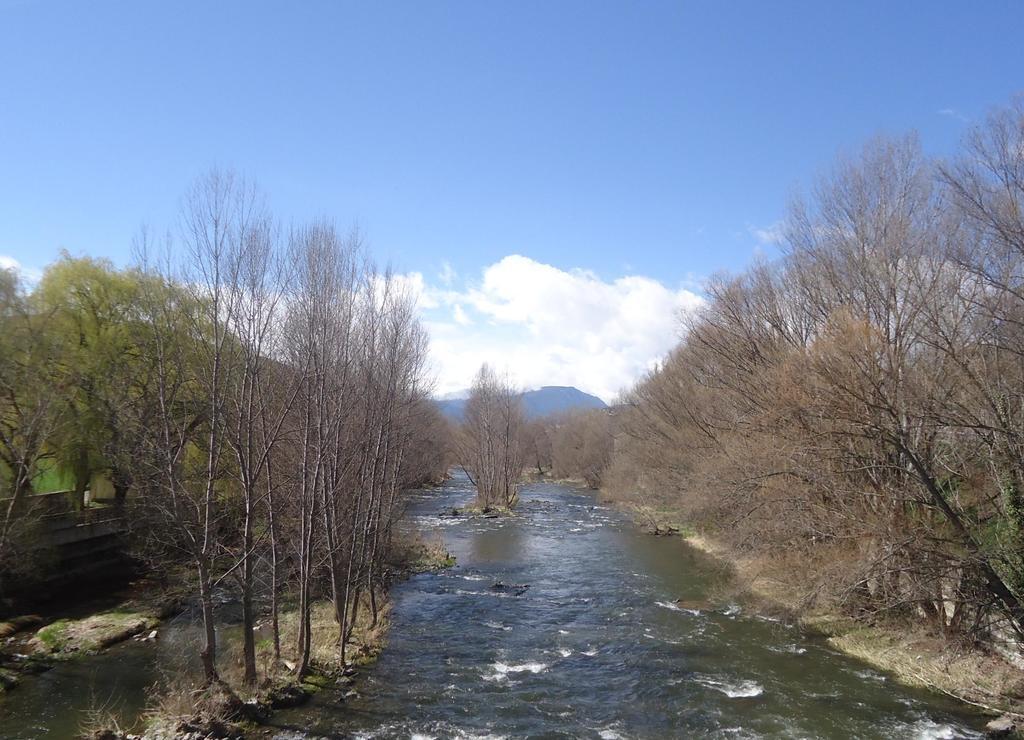Could you give a brief overview of what you see in this image? In this image we can see the water. Beside the water we can see the grass and a group of trees. On the left side, we can see a wall and trees. In the background, we can see the mountains. At the top we can see the sky. 